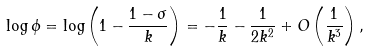Convert formula to latex. <formula><loc_0><loc_0><loc_500><loc_500>\log \phi = \log \left ( 1 - \frac { 1 - \sigma } { k } \right ) = - \frac { 1 } { k } - \frac { 1 } { 2 k ^ { 2 } } + O \left ( \frac { 1 } { k ^ { 3 } } \right ) ,</formula> 